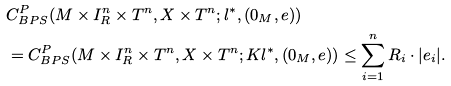<formula> <loc_0><loc_0><loc_500><loc_500>& C _ { B P S } ^ { P } ( M \times I _ { R } ^ { n } \times T ^ { n } , X \times T ^ { n } ; l ^ { \ast } , ( 0 _ { M } , e ) ) \\ & = C _ { B P S } ^ { P } ( M \times I _ { R } ^ { n } \times T ^ { n } , X \times T ^ { n } ; K l ^ { \ast } , ( 0 _ { M } , e ) ) \leq \sum _ { i = 1 } ^ { n } R _ { i } \cdot | e _ { i } | . \\</formula> 